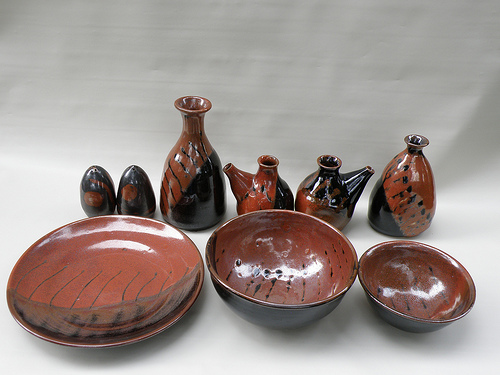Please provide a short description for this region: [0.04, 0.55, 0.4, 0.82]. In the region [0.04, 0.55, 0.4, 0.82], there is a large ceramic plate. This plate is intricately designed and serves as a key focal point in the image. 